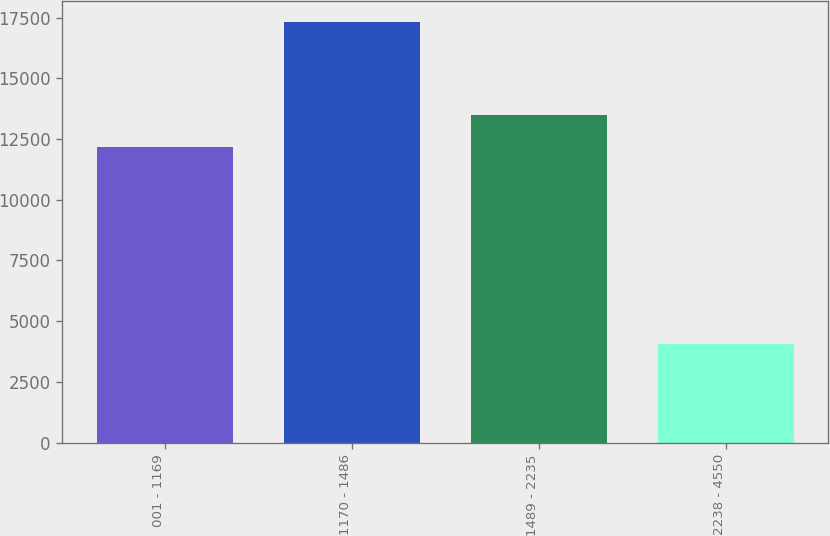Convert chart. <chart><loc_0><loc_0><loc_500><loc_500><bar_chart><fcel>001 - 1169<fcel>1170 - 1486<fcel>1489 - 2235<fcel>2238 - 4550<nl><fcel>12163<fcel>17341<fcel>13492.9<fcel>4042<nl></chart> 